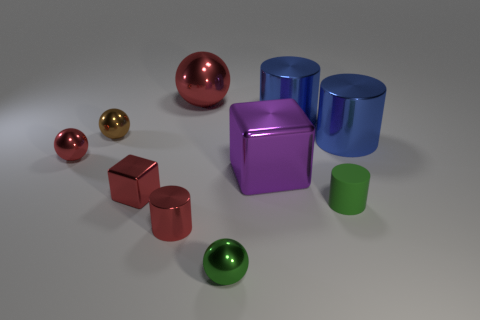There is another object that is the same shape as the purple thing; what material is it? The object sharing the same shape as the purple one appears to be made of a shiny, reflective metal, likely aluminum or steel, given its glossy finish and its ability to cast and reflect distinct light and shadow. 